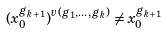<formula> <loc_0><loc_0><loc_500><loc_500>( x _ { 0 } ^ { g _ { k + 1 } } ) ^ { v ( g _ { 1 } , \dots , g _ { k } ) } \neq x _ { 0 } ^ { g _ { k + 1 } }</formula> 